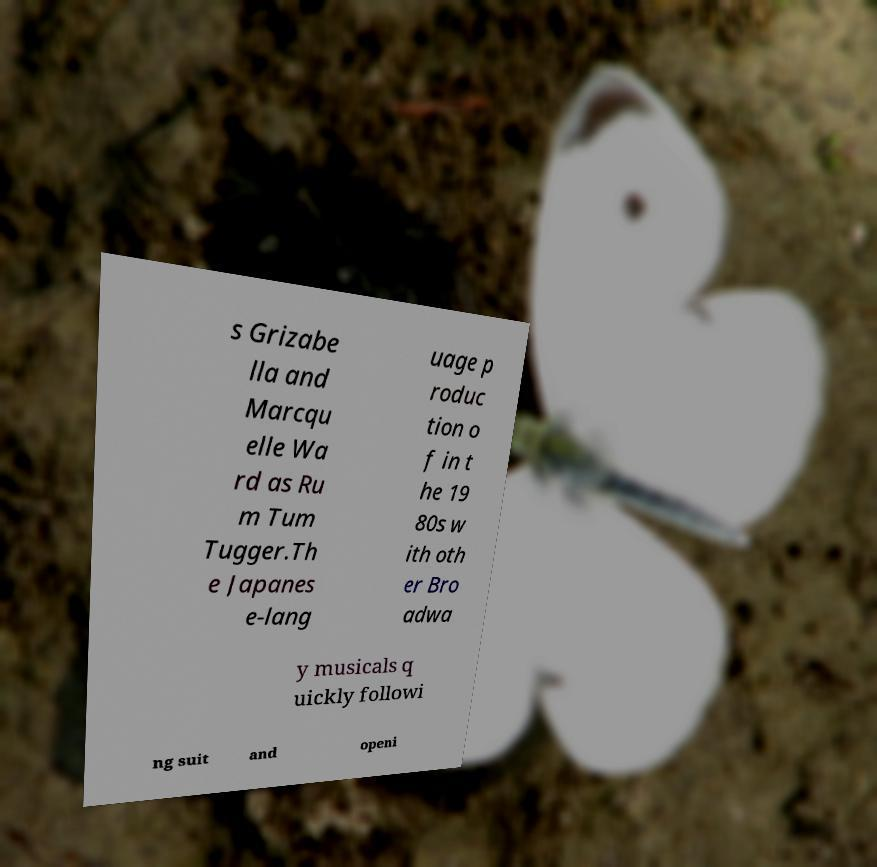I need the written content from this picture converted into text. Can you do that? s Grizabe lla and Marcqu elle Wa rd as Ru m Tum Tugger.Th e Japanes e-lang uage p roduc tion o f in t he 19 80s w ith oth er Bro adwa y musicals q uickly followi ng suit and openi 